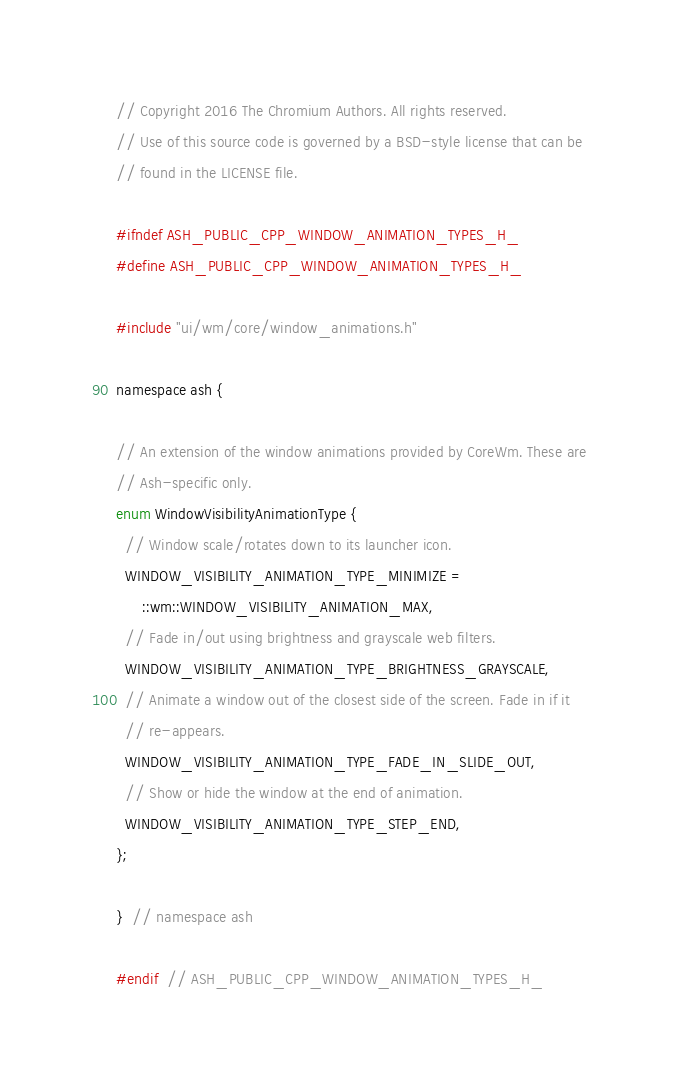Convert code to text. <code><loc_0><loc_0><loc_500><loc_500><_C_>// Copyright 2016 The Chromium Authors. All rights reserved.
// Use of this source code is governed by a BSD-style license that can be
// found in the LICENSE file.

#ifndef ASH_PUBLIC_CPP_WINDOW_ANIMATION_TYPES_H_
#define ASH_PUBLIC_CPP_WINDOW_ANIMATION_TYPES_H_

#include "ui/wm/core/window_animations.h"

namespace ash {

// An extension of the window animations provided by CoreWm. These are
// Ash-specific only.
enum WindowVisibilityAnimationType {
  // Window scale/rotates down to its launcher icon.
  WINDOW_VISIBILITY_ANIMATION_TYPE_MINIMIZE =
      ::wm::WINDOW_VISIBILITY_ANIMATION_MAX,
  // Fade in/out using brightness and grayscale web filters.
  WINDOW_VISIBILITY_ANIMATION_TYPE_BRIGHTNESS_GRAYSCALE,
  // Animate a window out of the closest side of the screen. Fade in if it
  // re-appears.
  WINDOW_VISIBILITY_ANIMATION_TYPE_FADE_IN_SLIDE_OUT,
  // Show or hide the window at the end of animation.
  WINDOW_VISIBILITY_ANIMATION_TYPE_STEP_END,
};

}  // namespace ash

#endif  // ASH_PUBLIC_CPP_WINDOW_ANIMATION_TYPES_H_
</code> 